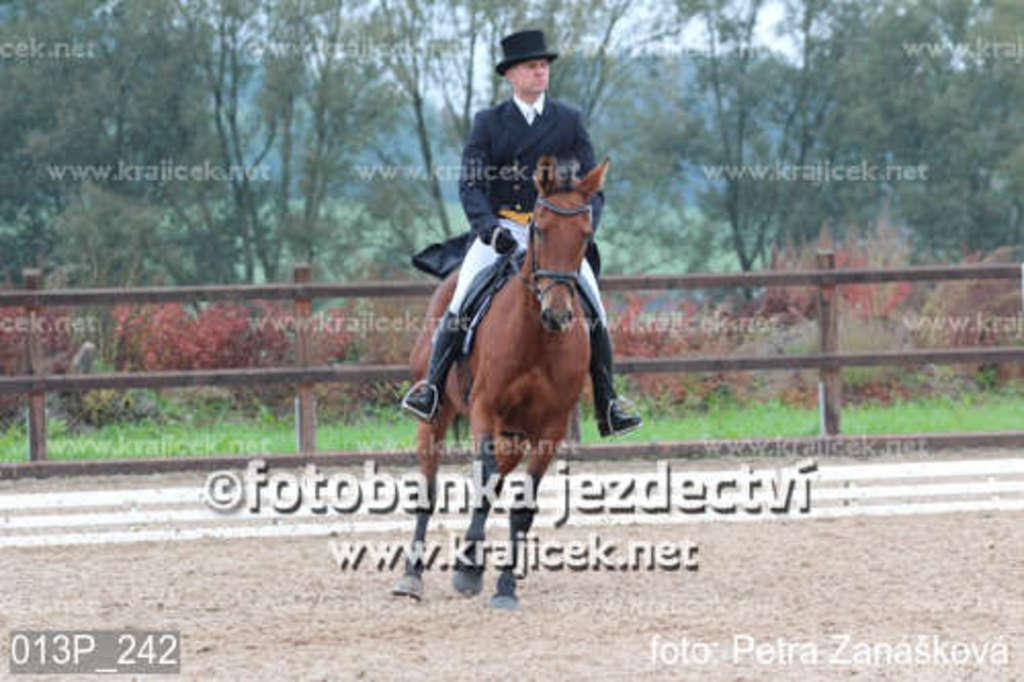What is the main subject of the image? There is a person in the image. What is the person doing in the image? The person is riding a horse. What can be seen in the background of the image? There is fencing and trees in the image. Is there any text present in the image? Yes, there is text at the bottom of the image. What type of beast can be seen in the garden in the image? There is no beast or garden present in the image. How many apples can be seen on the tree in the image? There are no apples or trees with apples present in the image. 